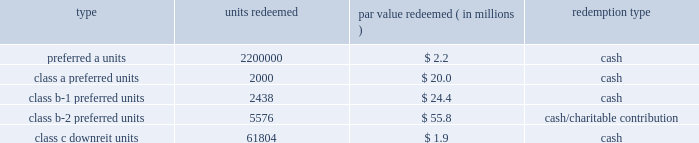Kimco realty corporation and subsidiaries notes to consolidated financial statements , continued the units consisted of ( i ) approximately 81.8 million preferred a units par value $ 1.00 per unit , which pay the holder a return of 7.0% ( 7.0 % ) per annum on the preferred a par value and are redeemable for cash by the holder at any time after one year or callable by the company any time after six months and contain a promote feature based upon an increase in net operating income of the properties capped at a 10.0% ( 10.0 % ) increase , ( ii ) 2000 class a preferred units , par value $ 10000 per unit , which pay the holder a return equal to libor plus 2.0% ( 2.0 % ) per annum on the class a preferred par value and are redeemable for cash by the holder at any time after november 30 , 2010 , ( iii ) 2627 class b-1 preferred units , par value $ 10000 per unit , which pay the holder a return equal to 7.0% ( 7.0 % ) per annum on the class b-1 preferred par value and are redeemable by the holder at any time after november 30 , 2010 , for cash or at the company 2019s option , shares of the company 2019s common stock , equal to the cash redemption amount , as defined , ( iv ) 5673 class b-2 preferred units , par value $ 10000 per unit , which pay the holder a return equal to 7.0% ( 7.0 % ) per annum on the class b-2 preferred par value and are redeemable for cash by the holder at any time after november 30 , 2010 , and ( v ) 640001 class c downreit units , valued at an issuance price of $ 30.52 per unit which pay the holder a return at a rate equal to the company 2019s common stock dividend and are redeemable by the holder at any time after november 30 , 2010 , for cash or at the company 2019s option , shares of the company 2019s common stock equal to the class c cash amount , as defined .
The following units have been redeemed as of december 31 , 2010 : redeemed par value redeemed ( in millions ) redemption type .
Noncontrolling interest relating to the remaining units was $ 110.4 million and $ 113.1 million as of december 31 , 2010 and 2009 , respectively .
During 2006 , the company acquired two shopping center properties located in bay shore and centereach , ny .
Included in noncontrolling interests was approximately $ 41.6 million , including a discount of $ 0.3 million and a fair market value adjustment of $ 3.8 million , in redeemable units ( the 201credeemable units 201d ) , issued by the company in connection with these transactions .
The prop- erties were acquired through the issuance of $ 24.2 million of redeemable units , which are redeemable at the option of the holder ; approximately $ 14.0 million of fixed rate redeemable units and the assumption of approximately $ 23.4 million of non-recourse debt .
The redeemable units consist of ( i ) 13963 class a units , par value $ 1000 per unit , which pay the holder a return of 5% ( 5 % ) per annum of the class a par value and are redeemable for cash by the holder at any time after april 3 , 2011 , or callable by the company any time after april 3 , 2016 , and ( ii ) 647758 class b units , valued at an issuance price of $ 37.24 per unit , which pay the holder a return at a rate equal to the company 2019s common stock dividend and are redeemable by the holder at any time after april 3 , 2007 , for cash or at the option of the company for common stock at a ratio of 1:1 , or callable by the company any time after april 3 , 2026 .
The company is restricted from disposing of these assets , other than through a tax free transaction , until april 2016 and april 2026 for the centereach , ny , and bay shore , ny , assets , respectively .
During 2007 , 30000 units , or $ 1.1 million par value , of theclass bunits were redeemed by the holder in cash at the option of the company .
Noncontrolling interest relating to the units was $ 40.4 million and $ 40.3 million as of december 31 , 2010 and 2009 , respectively .
Noncontrolling interests also includes 138015 convertible units issued during 2006 , by the company , which were valued at approxi- mately $ 5.3 million , including a fair market value adjustment of $ 0.3 million , related to an interest acquired in an office building located in albany , ny .
These units are redeemable at the option of the holder after one year for cash or at the option of the company for the company 2019s common stock at a ratio of 1:1 .
The holder is entitled to a distribution equal to the dividend rate of the company 2019s common stock .
The company is restricted from disposing of these assets , other than through a tax free transaction , until january 2017. .
What is the par value of the redeemed preferred a units , in millions? 
Computations: ((2200000 * 2.2) / 1000000)
Answer: 4.84. Kimco realty corporation and subsidiaries notes to consolidated financial statements , continued the units consisted of ( i ) approximately 81.8 million preferred a units par value $ 1.00 per unit , which pay the holder a return of 7.0% ( 7.0 % ) per annum on the preferred a par value and are redeemable for cash by the holder at any time after one year or callable by the company any time after six months and contain a promote feature based upon an increase in net operating income of the properties capped at a 10.0% ( 10.0 % ) increase , ( ii ) 2000 class a preferred units , par value $ 10000 per unit , which pay the holder a return equal to libor plus 2.0% ( 2.0 % ) per annum on the class a preferred par value and are redeemable for cash by the holder at any time after november 30 , 2010 , ( iii ) 2627 class b-1 preferred units , par value $ 10000 per unit , which pay the holder a return equal to 7.0% ( 7.0 % ) per annum on the class b-1 preferred par value and are redeemable by the holder at any time after november 30 , 2010 , for cash or at the company 2019s option , shares of the company 2019s common stock , equal to the cash redemption amount , as defined , ( iv ) 5673 class b-2 preferred units , par value $ 10000 per unit , which pay the holder a return equal to 7.0% ( 7.0 % ) per annum on the class b-2 preferred par value and are redeemable for cash by the holder at any time after november 30 , 2010 , and ( v ) 640001 class c downreit units , valued at an issuance price of $ 30.52 per unit which pay the holder a return at a rate equal to the company 2019s common stock dividend and are redeemable by the holder at any time after november 30 , 2010 , for cash or at the company 2019s option , shares of the company 2019s common stock equal to the class c cash amount , as defined .
The following units have been redeemed as of december 31 , 2010 : redeemed par value redeemed ( in millions ) redemption type .
Noncontrolling interest relating to the remaining units was $ 110.4 million and $ 113.1 million as of december 31 , 2010 and 2009 , respectively .
During 2006 , the company acquired two shopping center properties located in bay shore and centereach , ny .
Included in noncontrolling interests was approximately $ 41.6 million , including a discount of $ 0.3 million and a fair market value adjustment of $ 3.8 million , in redeemable units ( the 201credeemable units 201d ) , issued by the company in connection with these transactions .
The prop- erties were acquired through the issuance of $ 24.2 million of redeemable units , which are redeemable at the option of the holder ; approximately $ 14.0 million of fixed rate redeemable units and the assumption of approximately $ 23.4 million of non-recourse debt .
The redeemable units consist of ( i ) 13963 class a units , par value $ 1000 per unit , which pay the holder a return of 5% ( 5 % ) per annum of the class a par value and are redeemable for cash by the holder at any time after april 3 , 2011 , or callable by the company any time after april 3 , 2016 , and ( ii ) 647758 class b units , valued at an issuance price of $ 37.24 per unit , which pay the holder a return at a rate equal to the company 2019s common stock dividend and are redeemable by the holder at any time after april 3 , 2007 , for cash or at the option of the company for common stock at a ratio of 1:1 , or callable by the company any time after april 3 , 2026 .
The company is restricted from disposing of these assets , other than through a tax free transaction , until april 2016 and april 2026 for the centereach , ny , and bay shore , ny , assets , respectively .
During 2007 , 30000 units , or $ 1.1 million par value , of theclass bunits were redeemed by the holder in cash at the option of the company .
Noncontrolling interest relating to the units was $ 40.4 million and $ 40.3 million as of december 31 , 2010 and 2009 , respectively .
Noncontrolling interests also includes 138015 convertible units issued during 2006 , by the company , which were valued at approxi- mately $ 5.3 million , including a fair market value adjustment of $ 0.3 million , related to an interest acquired in an office building located in albany , ny .
These units are redeemable at the option of the holder after one year for cash or at the option of the company for the company 2019s common stock at a ratio of 1:1 .
The holder is entitled to a distribution equal to the dividend rate of the company 2019s common stock .
The company is restricted from disposing of these assets , other than through a tax free transaction , until january 2017. .
What is the percentage change in noncontrolling interest relating to the remaining units from 2009 to 2010? 
Computations: ((110.4 - 113.1) / 113.1)
Answer: -0.02387. 